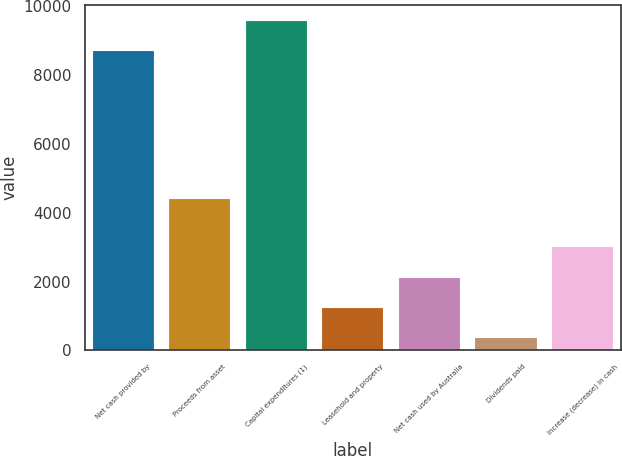Convert chart to OTSL. <chart><loc_0><loc_0><loc_500><loc_500><bar_chart><fcel>Net cash provided by<fcel>Proceeds from asset<fcel>Capital expenditures (1)<fcel>Leasehold and property<fcel>Net cash used by Australia<fcel>Dividends paid<fcel>Increase (decrease) in cash<nl><fcel>8685<fcel>4405<fcel>9561.7<fcel>1236.7<fcel>2113.4<fcel>360<fcel>2990.1<nl></chart> 